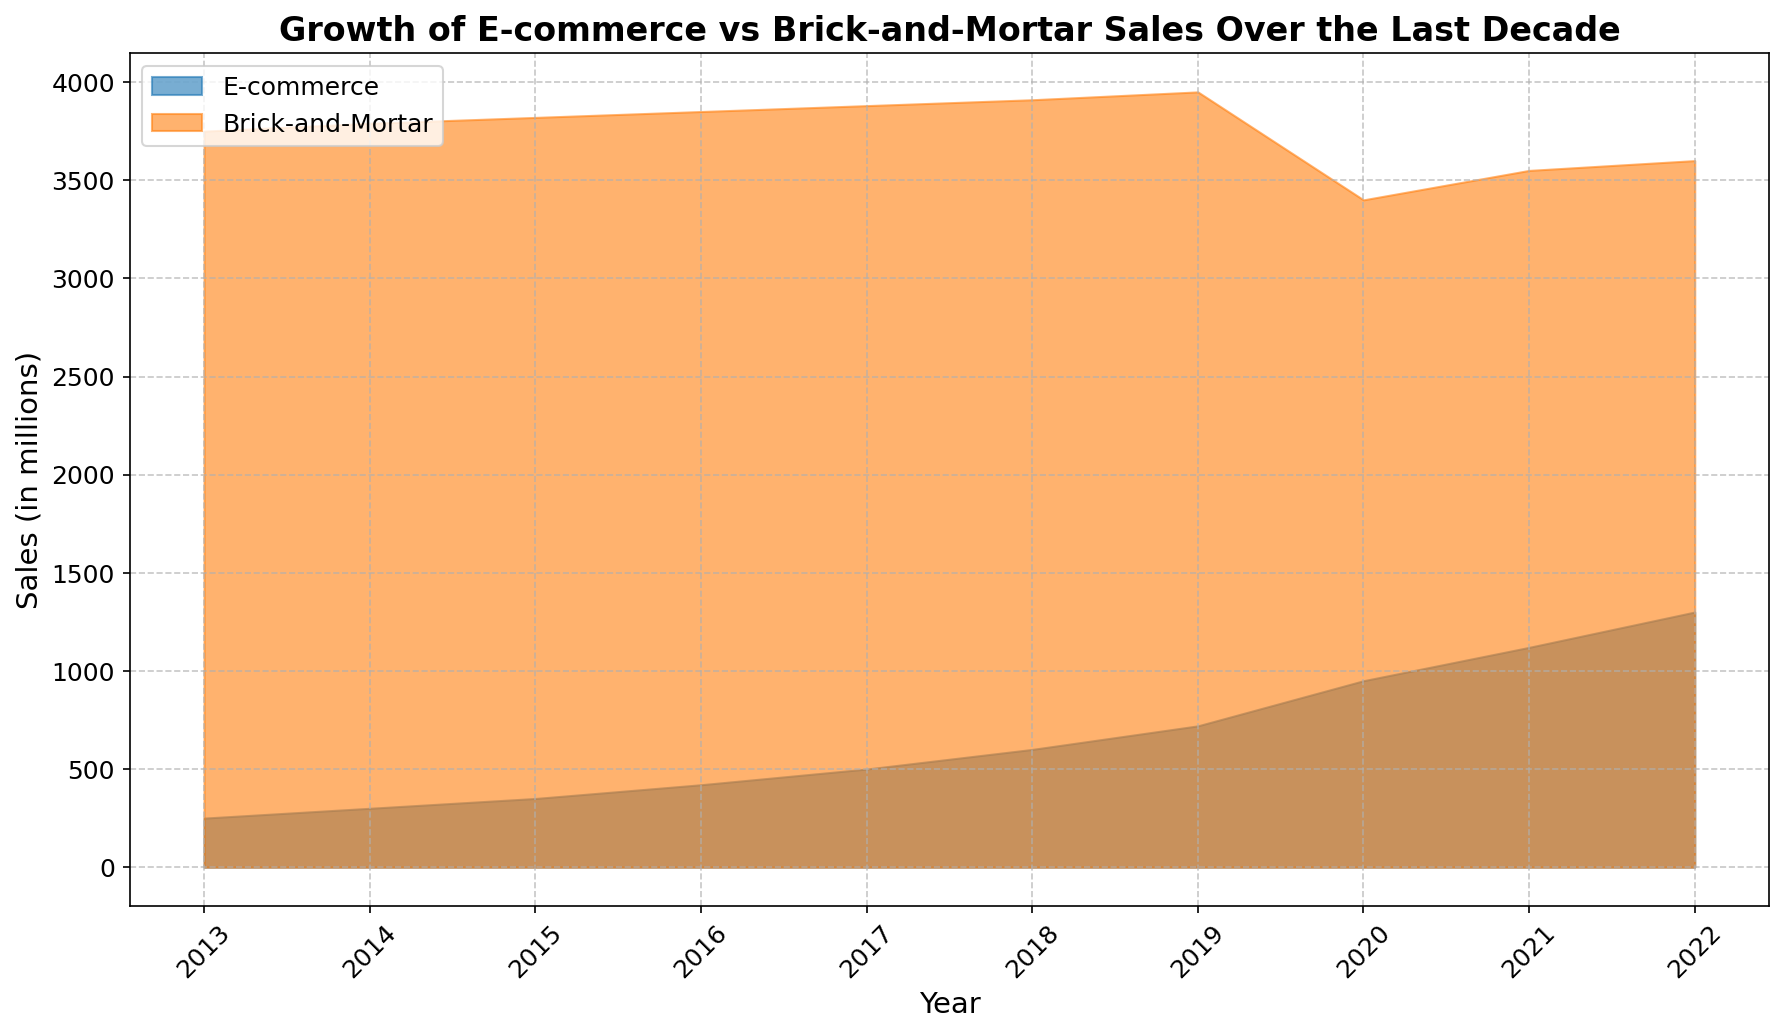What is the trend of E-commerce sales over the decade? From the figure, E-commerce sales show a consistent upward trend across all years from 2013 to 2022, with significant growth especially noticeable from 2018 onwards.
Answer: Consistent upward trend How does the trend of Brick-and-Mortar sales compare to E-commerce sales? Brick-and-Mortar sales show a relatively stable trend with slight increases from 2013 to 2019, but a drop in 2020 followed by a recovery. E-commerce sales, on the other hand, show a continuous and more significant increase, especially from 2018 onwards.
Answer: E-commerce shows more significant growth What year did E-commerce sales surpass 1000 million? The figure shows that E-commerce sales surpass 1000 million in the year 2021.
Answer: 2021 Compare the sales figures of E-commerce and Brick-and-Mortar in the year 2020. In the year 2020, E-commerce sales are approximately 950 million, whereas Brick-and-Mortar sales are approximately 3400 million.
Answer: E-commerce: 950 million, Brick-and-Mortar: 3400 million Which year shows the highest growth in E-commerce sales? By visually inspecting the figure, the year with the highest noticeable increase in E-commerce sales appears to be between 2019 and 2020.
Answer: Between 2019 and 2020 In which year do Brick-and-Mortar sales show a noticeable drop, and what can be the possible reason? The year 2020 shows a noticeable drop in Brick-and-Mortar sales. This could possibly be attributed to the COVID-19 pandemic impacting in-person shopping during that period.
Answer: 2020, likely due to COVID-19 What is the approximate difference in sales between E-commerce and Brick-and-Mortar sales in 2022? For 2022, E-commerce sales are approximately 1300 million, and Brick-and-Mortar sales are approximately 3600 million. The difference is 3600 - 1300 = 2300 million.
Answer: 2300 million What is the color used to represent Brick-and-Mortar sales in the chart? The visual representation of Brick-and-Mortar sales in the chart uses an orange color.
Answer: Orange Which segment (E-commerce or Brick-and-Mortar) demonstrates more stability in sales over the decade? Brick-and-Mortar sales demonstrate more stability over the decade as they exhibit minor fluctuations compared to the consistently rising trend of E-commerce sales.
Answer: Brick-and-Mortar Calculate the average annual increase in E-commerce sales over the last decade. From the figure, E-commerce sales in 2013 were 250 million and in 2022 they were 1300 million. The total increase is 1300 - 250 = 1050 million over 10 years. The average annual increase is 1050 / 10 = 105 million.
Answer: 105 million 